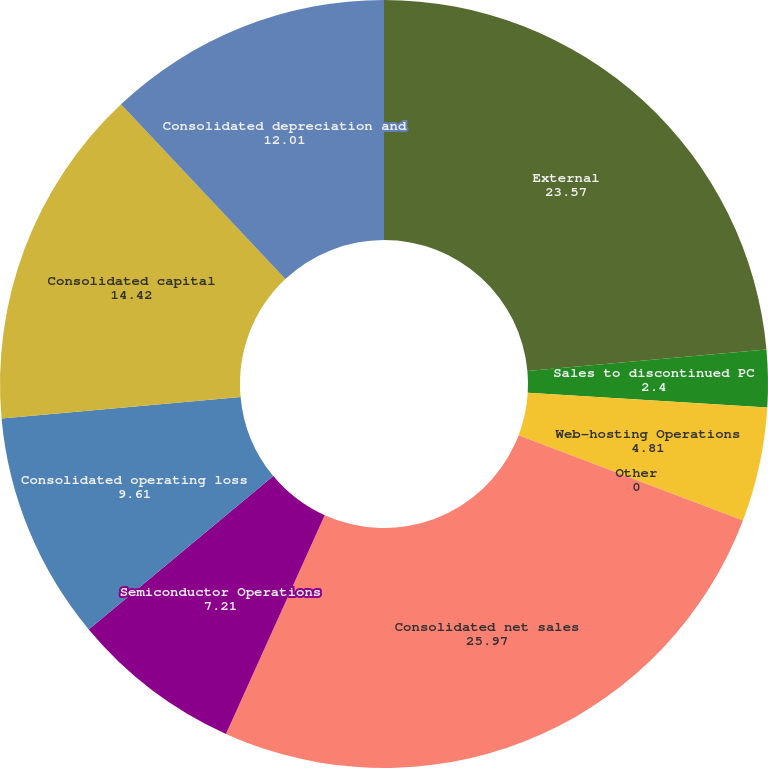<chart> <loc_0><loc_0><loc_500><loc_500><pie_chart><fcel>External<fcel>Sales to discontinued PC<fcel>Web-hosting Operations<fcel>Other<fcel>Consolidated net sales<fcel>Semiconductor Operations<fcel>Consolidated operating loss<fcel>Consolidated capital<fcel>Consolidated depreciation and<nl><fcel>23.57%<fcel>2.4%<fcel>4.81%<fcel>0.0%<fcel>25.97%<fcel>7.21%<fcel>9.61%<fcel>14.42%<fcel>12.01%<nl></chart> 